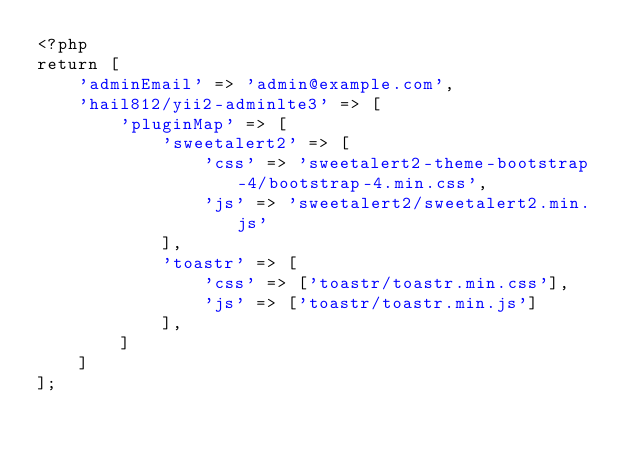Convert code to text. <code><loc_0><loc_0><loc_500><loc_500><_PHP_><?php
return [
    'adminEmail' => 'admin@example.com',
    'hail812/yii2-adminlte3' => [
        'pluginMap' => [
            'sweetalert2' => [
                'css' => 'sweetalert2-theme-bootstrap-4/bootstrap-4.min.css',
                'js' => 'sweetalert2/sweetalert2.min.js'
            ],
            'toastr' => [
                'css' => ['toastr/toastr.min.css'],
                'js' => ['toastr/toastr.min.js']
            ],
        ]
    ]
];</code> 